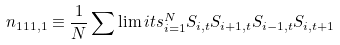Convert formula to latex. <formula><loc_0><loc_0><loc_500><loc_500>n _ { 1 1 1 , 1 } \equiv \frac { 1 } { N } \sum \lim i t s _ { i = 1 } ^ { N } { S _ { i , t } S _ { i + 1 , t } S _ { i - 1 , t } S _ { i , t + 1 } }</formula> 